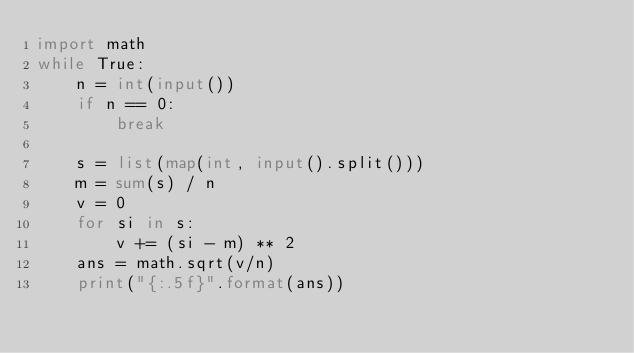Convert code to text. <code><loc_0><loc_0><loc_500><loc_500><_Python_>import math
while True:
    n = int(input())
    if n == 0:
        break

    s = list(map(int, input().split()))
    m = sum(s) / n
    v = 0
    for si in s:
        v += (si - m) ** 2
    ans = math.sqrt(v/n)      
    print("{:.5f}".format(ans))
</code> 